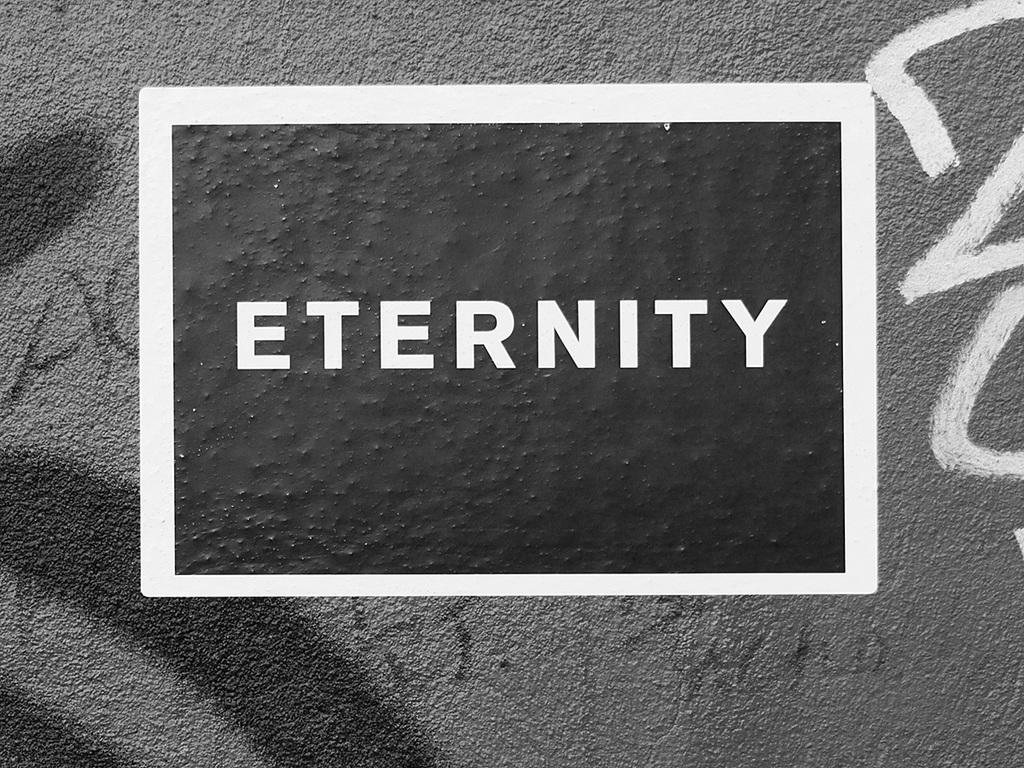<image>
Create a compact narrative representing the image presented. Wall with a sticker that says Eternity in white. 